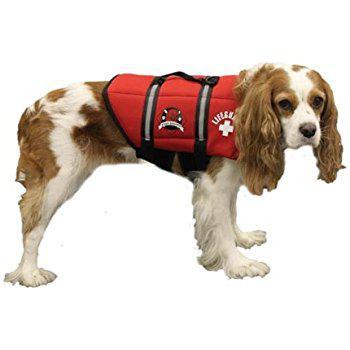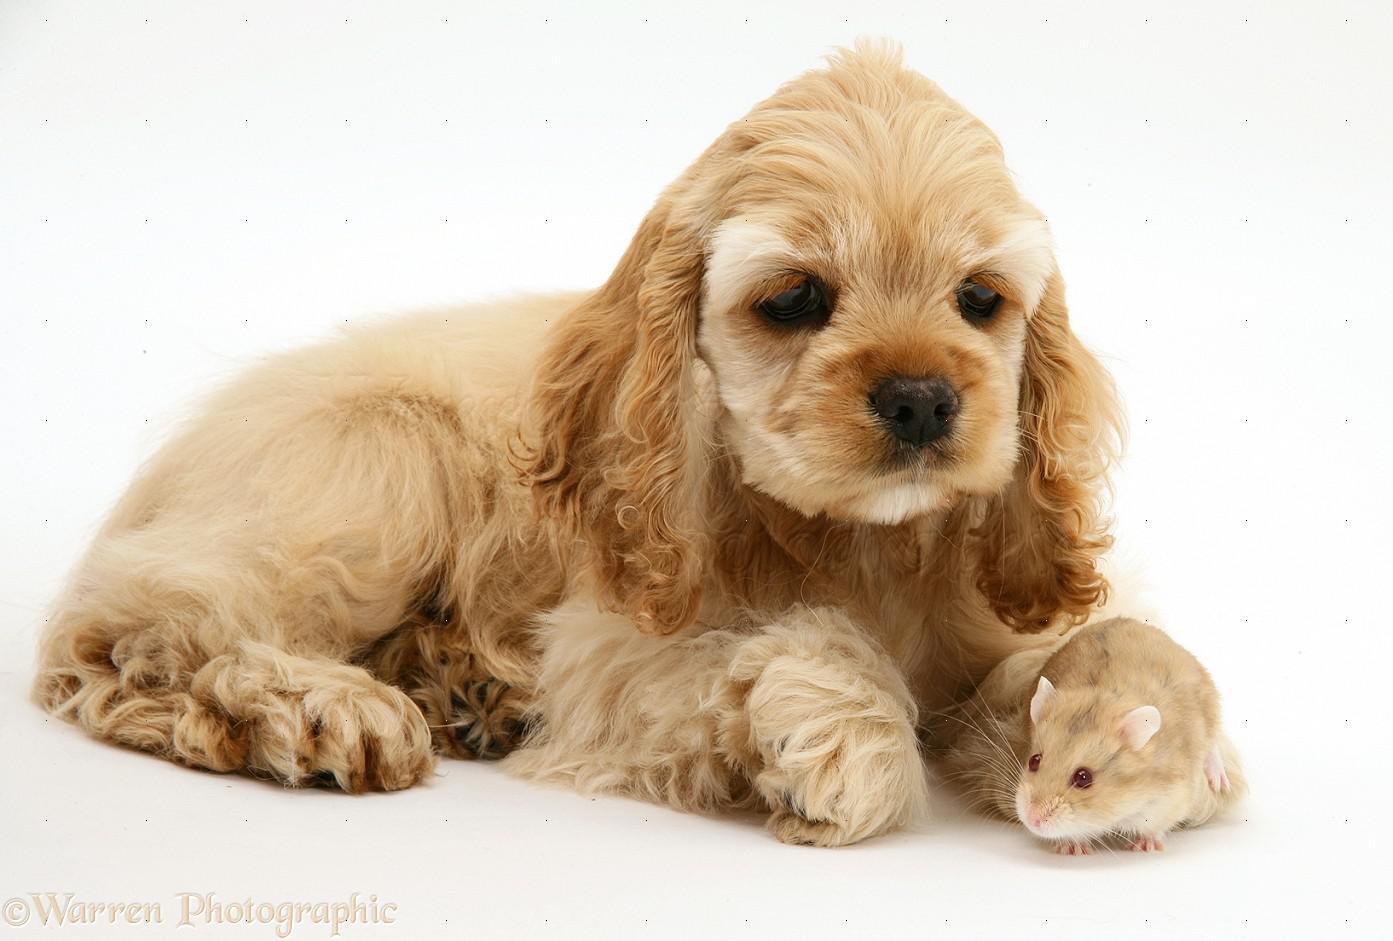The first image is the image on the left, the second image is the image on the right. Examine the images to the left and right. Is the description "There is a total of 1 or more dogs whose bodies are facing right." accurate? Answer yes or no. Yes. 